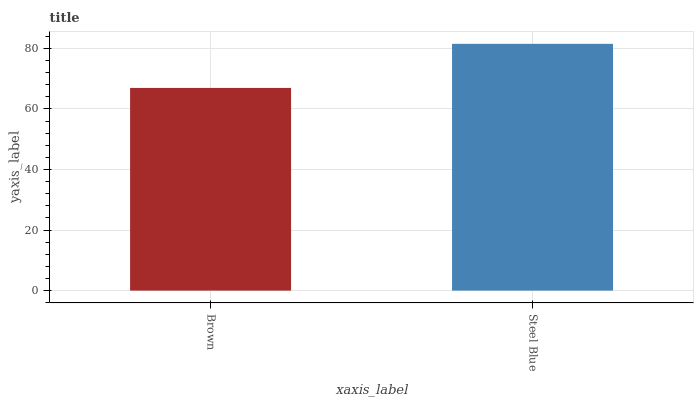Is Brown the minimum?
Answer yes or no. Yes. Is Steel Blue the maximum?
Answer yes or no. Yes. Is Steel Blue the minimum?
Answer yes or no. No. Is Steel Blue greater than Brown?
Answer yes or no. Yes. Is Brown less than Steel Blue?
Answer yes or no. Yes. Is Brown greater than Steel Blue?
Answer yes or no. No. Is Steel Blue less than Brown?
Answer yes or no. No. Is Steel Blue the high median?
Answer yes or no. Yes. Is Brown the low median?
Answer yes or no. Yes. Is Brown the high median?
Answer yes or no. No. Is Steel Blue the low median?
Answer yes or no. No. 